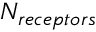Convert formula to latex. <formula><loc_0><loc_0><loc_500><loc_500>N _ { r e c e p t o r s }</formula> 